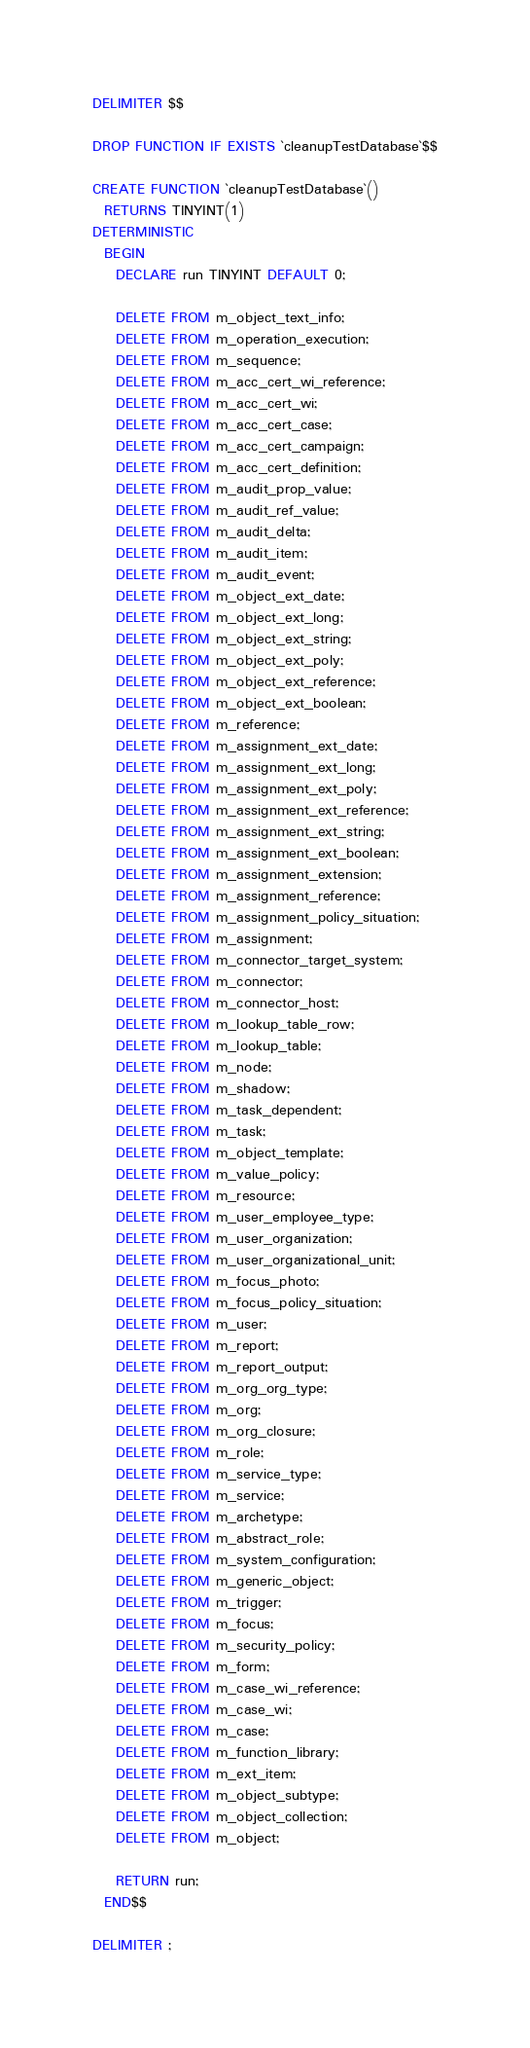Convert code to text. <code><loc_0><loc_0><loc_500><loc_500><_SQL_>DELIMITER $$

DROP FUNCTION IF EXISTS `cleanupTestDatabase`$$

CREATE FUNCTION `cleanupTestDatabase`()
  RETURNS TINYINT(1)
DETERMINISTIC
  BEGIN
    DECLARE run TINYINT DEFAULT 0;

    DELETE FROM m_object_text_info;
    DELETE FROM m_operation_execution;
    DELETE FROM m_sequence;
    DELETE FROM m_acc_cert_wi_reference;
    DELETE FROM m_acc_cert_wi;
    DELETE FROM m_acc_cert_case;
    DELETE FROM m_acc_cert_campaign;
    DELETE FROM m_acc_cert_definition;
    DELETE FROM m_audit_prop_value;
    DELETE FROM m_audit_ref_value;
    DELETE FROM m_audit_delta;
    DELETE FROM m_audit_item;
    DELETE FROM m_audit_event;
    DELETE FROM m_object_ext_date;
    DELETE FROM m_object_ext_long;
    DELETE FROM m_object_ext_string;
    DELETE FROM m_object_ext_poly;
    DELETE FROM m_object_ext_reference;
    DELETE FROM m_object_ext_boolean;
    DELETE FROM m_reference;
    DELETE FROM m_assignment_ext_date;
    DELETE FROM m_assignment_ext_long;
    DELETE FROM m_assignment_ext_poly;
    DELETE FROM m_assignment_ext_reference;
    DELETE FROM m_assignment_ext_string;
    DELETE FROM m_assignment_ext_boolean;
    DELETE FROM m_assignment_extension;
    DELETE FROM m_assignment_reference;
    DELETE FROM m_assignment_policy_situation;
    DELETE FROM m_assignment;
    DELETE FROM m_connector_target_system;
    DELETE FROM m_connector;
    DELETE FROM m_connector_host;
    DELETE FROM m_lookup_table_row;
    DELETE FROM m_lookup_table;
    DELETE FROM m_node;
    DELETE FROM m_shadow;
    DELETE FROM m_task_dependent;
    DELETE FROM m_task;
    DELETE FROM m_object_template;
    DELETE FROM m_value_policy;
    DELETE FROM m_resource;
    DELETE FROM m_user_employee_type;
    DELETE FROM m_user_organization;
    DELETE FROM m_user_organizational_unit;
    DELETE FROM m_focus_photo;
    DELETE FROM m_focus_policy_situation;
    DELETE FROM m_user;
    DELETE FROM m_report;
    DELETE FROM m_report_output;
    DELETE FROM m_org_org_type;
    DELETE FROM m_org;
    DELETE FROM m_org_closure;
    DELETE FROM m_role;
    DELETE FROM m_service_type;
    DELETE FROM m_service;
    DELETE FROM m_archetype;
    DELETE FROM m_abstract_role;
    DELETE FROM m_system_configuration;
    DELETE FROM m_generic_object;
    DELETE FROM m_trigger;
    DELETE FROM m_focus;
    DELETE FROM m_security_policy;
    DELETE FROM m_form;
    DELETE FROM m_case_wi_reference;
    DELETE FROM m_case_wi;
    DELETE FROM m_case;
    DELETE FROM m_function_library;
    DELETE FROM m_ext_item;
    DELETE FROM m_object_subtype;
    DELETE FROM m_object_collection;
    DELETE FROM m_object;

    RETURN run;
  END$$

DELIMITER ;</code> 